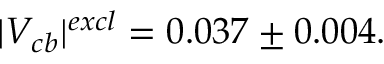Convert formula to latex. <formula><loc_0><loc_0><loc_500><loc_500>| V _ { c b } | ^ { e x c l } = 0 . 0 3 7 \pm 0 . 0 0 4 .</formula> 